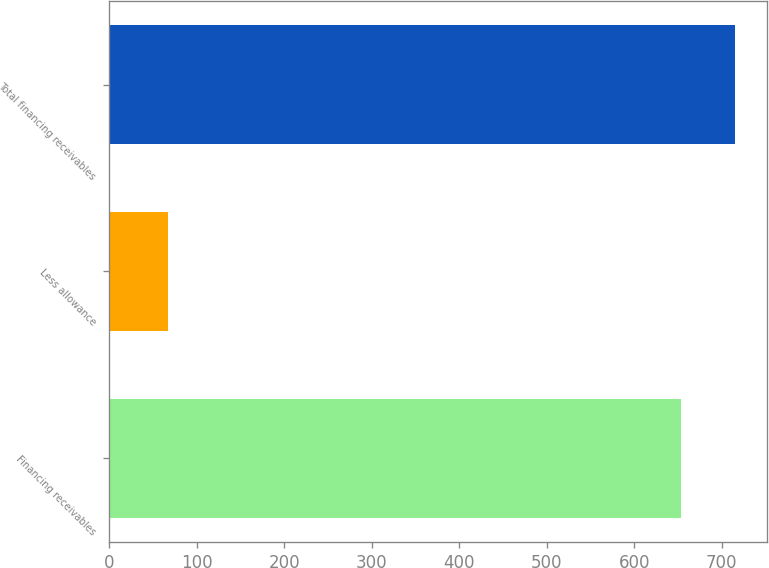Convert chart. <chart><loc_0><loc_0><loc_500><loc_500><bar_chart><fcel>Financing receivables<fcel>Less allowance<fcel>Total financing receivables<nl><fcel>654<fcel>67<fcel>715.4<nl></chart> 